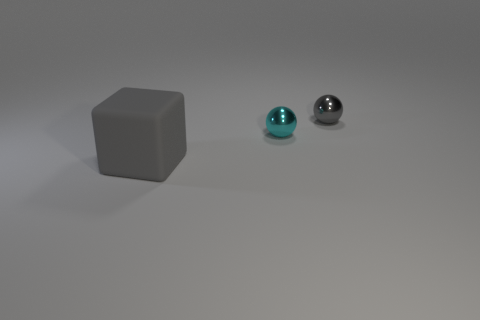Is there any other thing that has the same shape as the large rubber thing?
Your response must be concise. No. The other tiny metal thing that is the same shape as the cyan shiny thing is what color?
Make the answer very short. Gray. What number of objects are either brown matte cylinders or gray objects that are on the right side of the big gray block?
Offer a very short reply. 1. Are there fewer gray shiny things that are in front of the large gray matte thing than large gray objects?
Your answer should be compact. Yes. There is a cyan object that is in front of the gray object behind the tiny ball in front of the small gray ball; what size is it?
Offer a very short reply. Small. There is a object that is both behind the gray rubber thing and in front of the gray shiny sphere; what is its color?
Your answer should be very brief. Cyan. How many small gray shiny spheres are there?
Offer a terse response. 1. Is there anything else that has the same size as the cube?
Make the answer very short. No. Is the material of the small gray object the same as the block?
Provide a short and direct response. No. There is a gray thing that is on the right side of the rubber thing; is its size the same as the ball in front of the tiny gray metallic object?
Provide a succinct answer. Yes. 